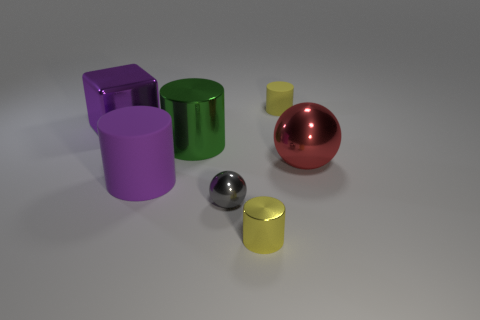Subtract 2 cylinders. How many cylinders are left? 2 Add 3 large green metallic objects. How many objects exist? 10 Subtract all cylinders. How many objects are left? 3 Add 1 small red matte cylinders. How many small red matte cylinders exist? 1 Subtract 0 cyan balls. How many objects are left? 7 Subtract all large metallic cylinders. Subtract all small gray things. How many objects are left? 5 Add 3 metal things. How many metal things are left? 8 